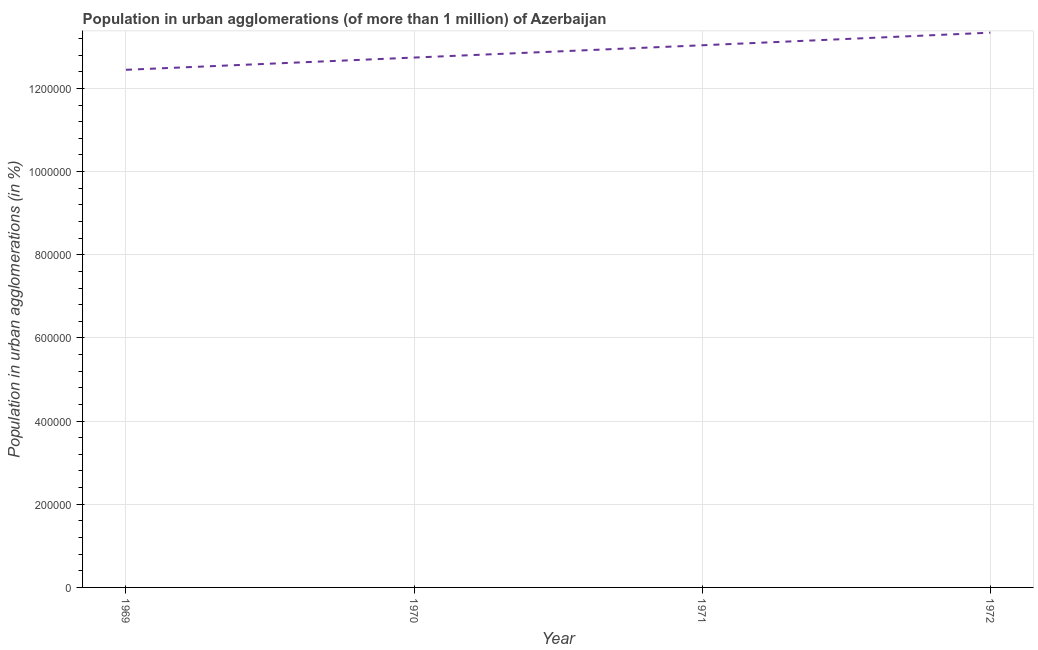What is the population in urban agglomerations in 1970?
Provide a short and direct response. 1.27e+06. Across all years, what is the maximum population in urban agglomerations?
Your answer should be compact. 1.33e+06. Across all years, what is the minimum population in urban agglomerations?
Your response must be concise. 1.24e+06. In which year was the population in urban agglomerations maximum?
Provide a short and direct response. 1972. In which year was the population in urban agglomerations minimum?
Provide a succinct answer. 1969. What is the sum of the population in urban agglomerations?
Offer a very short reply. 5.16e+06. What is the difference between the population in urban agglomerations in 1971 and 1972?
Your answer should be very brief. -3.03e+04. What is the average population in urban agglomerations per year?
Your response must be concise. 1.29e+06. What is the median population in urban agglomerations?
Offer a terse response. 1.29e+06. Do a majority of the years between 1971 and 1972 (inclusive) have population in urban agglomerations greater than 120000 %?
Offer a very short reply. Yes. What is the ratio of the population in urban agglomerations in 1969 to that in 1971?
Provide a succinct answer. 0.95. Is the difference between the population in urban agglomerations in 1969 and 1971 greater than the difference between any two years?
Offer a very short reply. No. What is the difference between the highest and the second highest population in urban agglomerations?
Offer a terse response. 3.03e+04. What is the difference between the highest and the lowest population in urban agglomerations?
Provide a short and direct response. 8.93e+04. In how many years, is the population in urban agglomerations greater than the average population in urban agglomerations taken over all years?
Provide a short and direct response. 2. Does the population in urban agglomerations monotonically increase over the years?
Provide a short and direct response. Yes. Are the values on the major ticks of Y-axis written in scientific E-notation?
Ensure brevity in your answer.  No. Does the graph contain any zero values?
Provide a short and direct response. No. What is the title of the graph?
Provide a short and direct response. Population in urban agglomerations (of more than 1 million) of Azerbaijan. What is the label or title of the X-axis?
Provide a short and direct response. Year. What is the label or title of the Y-axis?
Your answer should be very brief. Population in urban agglomerations (in %). What is the Population in urban agglomerations (in %) in 1969?
Your answer should be very brief. 1.24e+06. What is the Population in urban agglomerations (in %) in 1970?
Your answer should be compact. 1.27e+06. What is the Population in urban agglomerations (in %) of 1971?
Ensure brevity in your answer.  1.30e+06. What is the Population in urban agglomerations (in %) in 1972?
Your response must be concise. 1.33e+06. What is the difference between the Population in urban agglomerations (in %) in 1969 and 1970?
Keep it short and to the point. -2.94e+04. What is the difference between the Population in urban agglomerations (in %) in 1969 and 1971?
Give a very brief answer. -5.90e+04. What is the difference between the Population in urban agglomerations (in %) in 1969 and 1972?
Your response must be concise. -8.93e+04. What is the difference between the Population in urban agglomerations (in %) in 1970 and 1971?
Make the answer very short. -2.96e+04. What is the difference between the Population in urban agglomerations (in %) in 1970 and 1972?
Make the answer very short. -5.98e+04. What is the difference between the Population in urban agglomerations (in %) in 1971 and 1972?
Make the answer very short. -3.03e+04. What is the ratio of the Population in urban agglomerations (in %) in 1969 to that in 1971?
Ensure brevity in your answer.  0.95. What is the ratio of the Population in urban agglomerations (in %) in 1969 to that in 1972?
Your answer should be very brief. 0.93. What is the ratio of the Population in urban agglomerations (in %) in 1970 to that in 1972?
Make the answer very short. 0.95. 